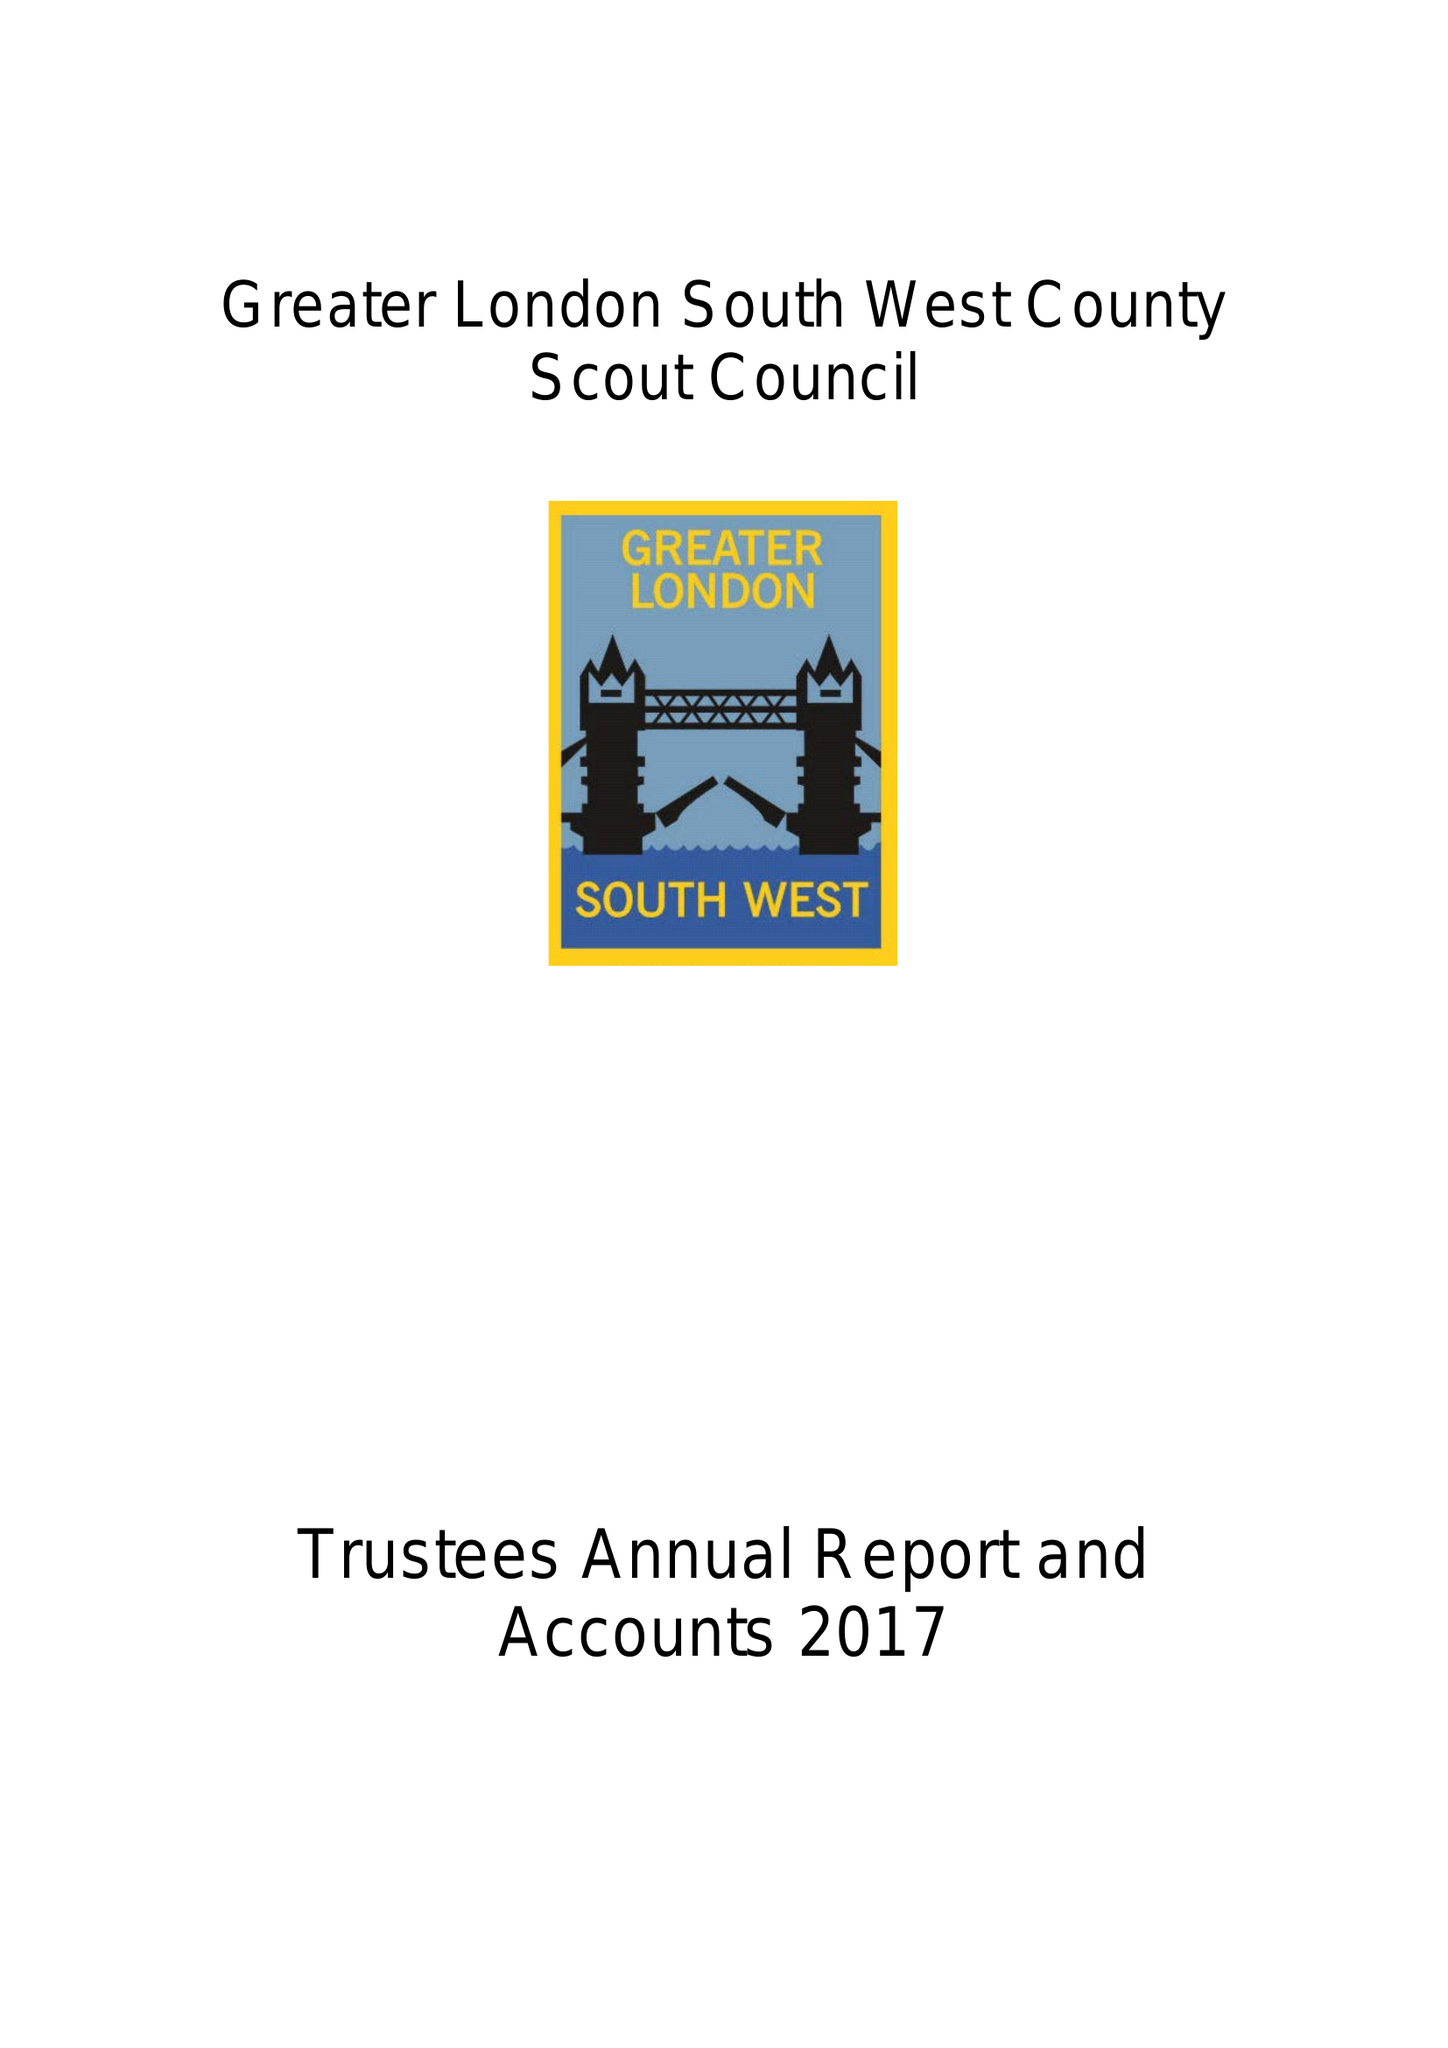What is the value for the charity_name?
Answer the question using a single word or phrase. Greater London, South West County Scout Council 